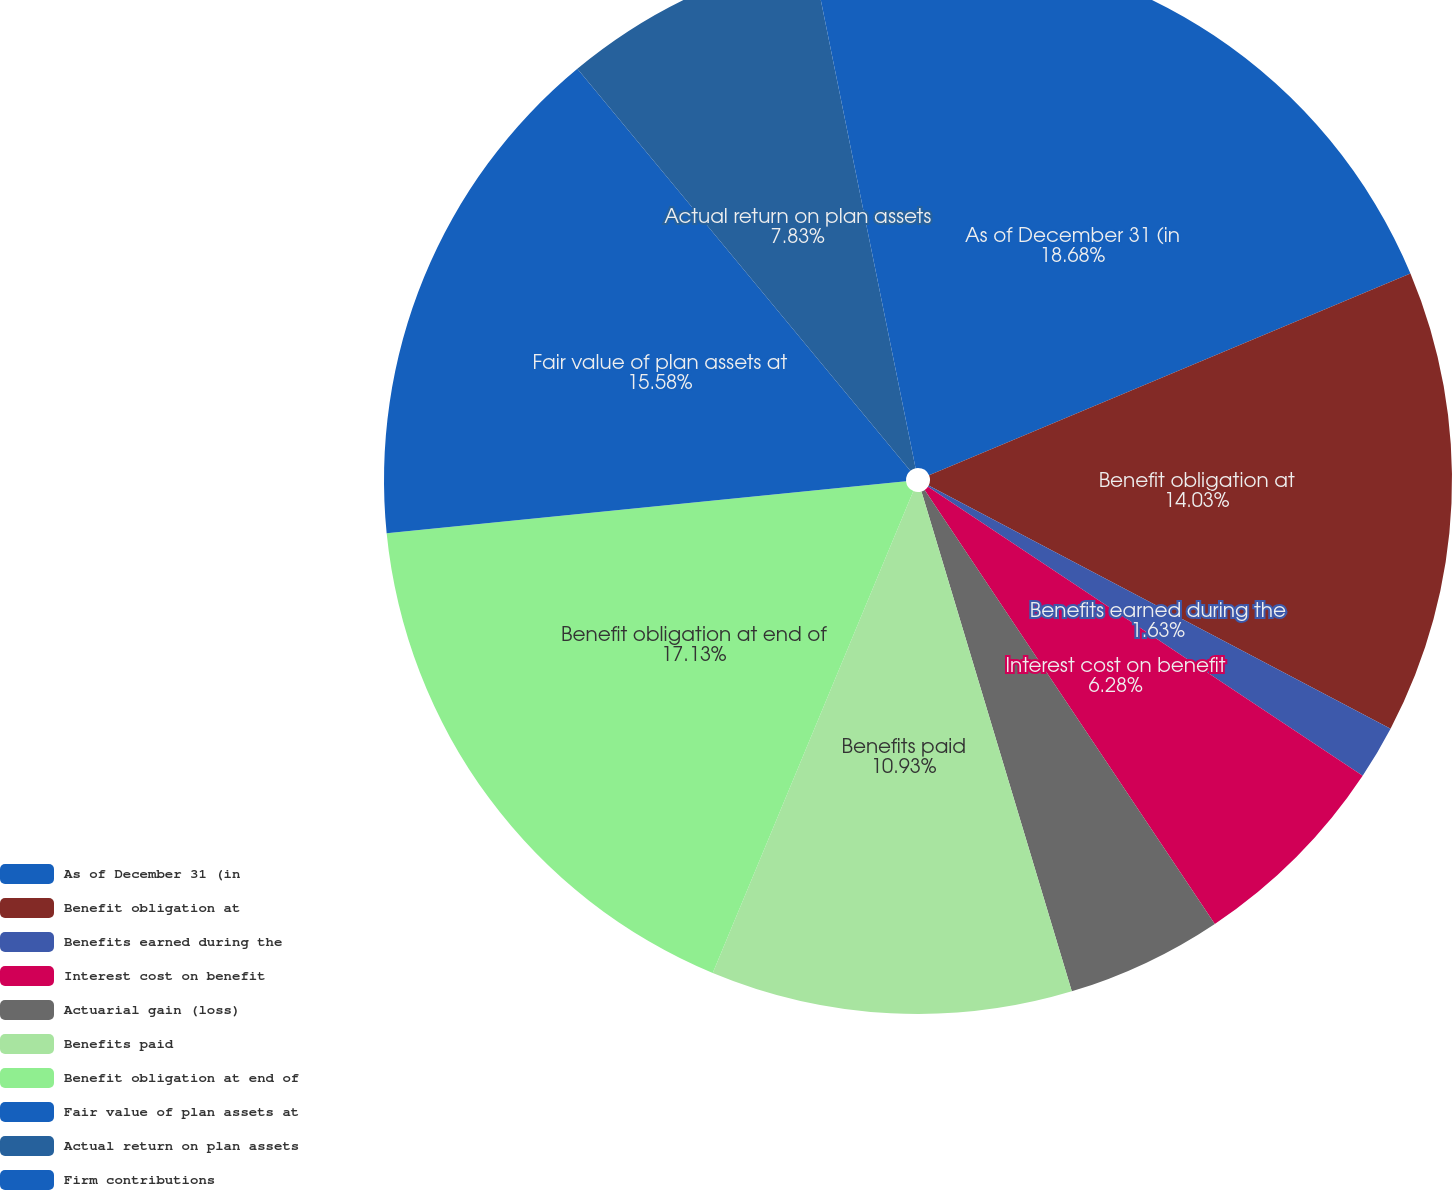Convert chart. <chart><loc_0><loc_0><loc_500><loc_500><pie_chart><fcel>As of December 31 (in<fcel>Benefit obligation at<fcel>Benefits earned during the<fcel>Interest cost on benefit<fcel>Actuarial gain (loss)<fcel>Benefits paid<fcel>Benefit obligation at end of<fcel>Fair value of plan assets at<fcel>Actual return on plan assets<fcel>Firm contributions<nl><fcel>18.68%<fcel>14.03%<fcel>1.63%<fcel>6.28%<fcel>4.73%<fcel>10.93%<fcel>17.13%<fcel>15.58%<fcel>7.83%<fcel>3.18%<nl></chart> 